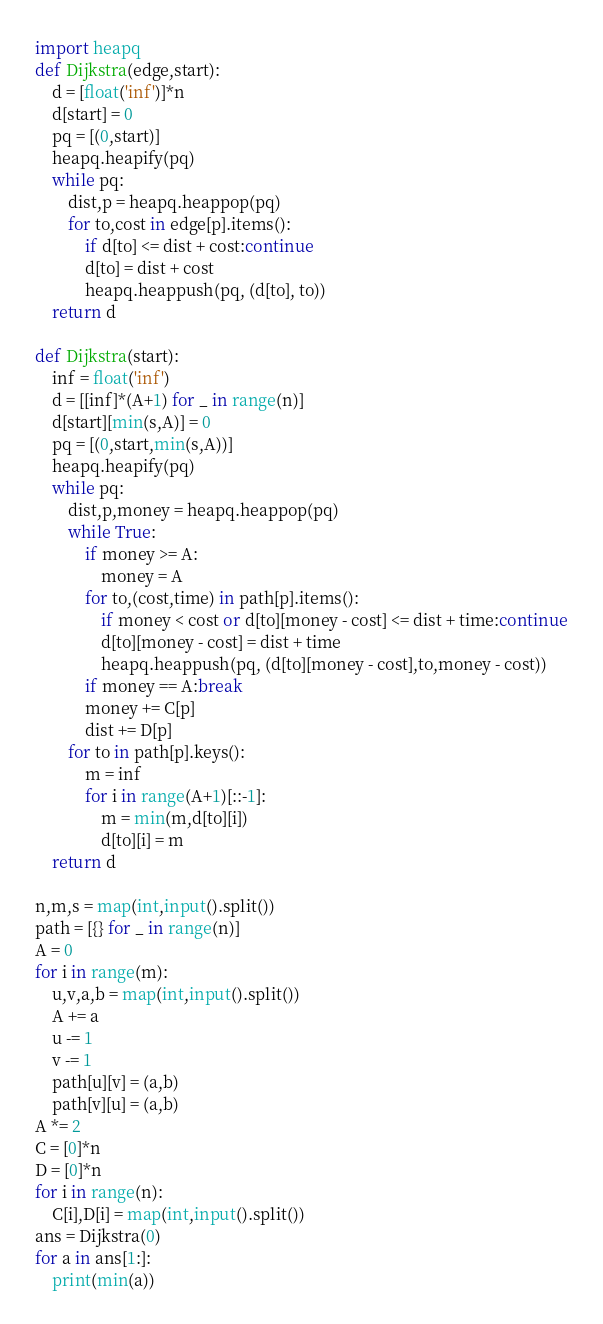<code> <loc_0><loc_0><loc_500><loc_500><_Python_>import heapq
def Dijkstra(edge,start):
    d = [float('inf')]*n
    d[start] = 0
    pq = [(0,start)]
    heapq.heapify(pq)
    while pq:
        dist,p = heapq.heappop(pq)
        for to,cost in edge[p].items():
            if d[to] <= dist + cost:continue
            d[to] = dist + cost
            heapq.heappush(pq, (d[to], to))
    return d

def Dijkstra(start):
    inf = float('inf')
    d = [[inf]*(A+1) for _ in range(n)]
    d[start][min(s,A)] = 0
    pq = [(0,start,min(s,A))]
    heapq.heapify(pq)
    while pq:
        dist,p,money = heapq.heappop(pq)
        while True:
            if money >= A:
                money = A
            for to,(cost,time) in path[p].items():
                if money < cost or d[to][money - cost] <= dist + time:continue
                d[to][money - cost] = dist + time
                heapq.heappush(pq, (d[to][money - cost],to,money - cost))
            if money == A:break
            money += C[p]
            dist += D[p]
        for to in path[p].keys():
            m = inf
            for i in range(A+1)[::-1]:
                m = min(m,d[to][i])
                d[to][i] = m
    return d

n,m,s = map(int,input().split())
path = [{} for _ in range(n)]
A = 0
for i in range(m):
    u,v,a,b = map(int,input().split())
    A += a
    u -= 1
    v -= 1
    path[u][v] = (a,b)
    path[v][u] = (a,b)
A *= 2
C = [0]*n
D = [0]*n
for i in range(n):
    C[i],D[i] = map(int,input().split())
ans = Dijkstra(0)
for a in ans[1:]:
    print(min(a))
</code> 